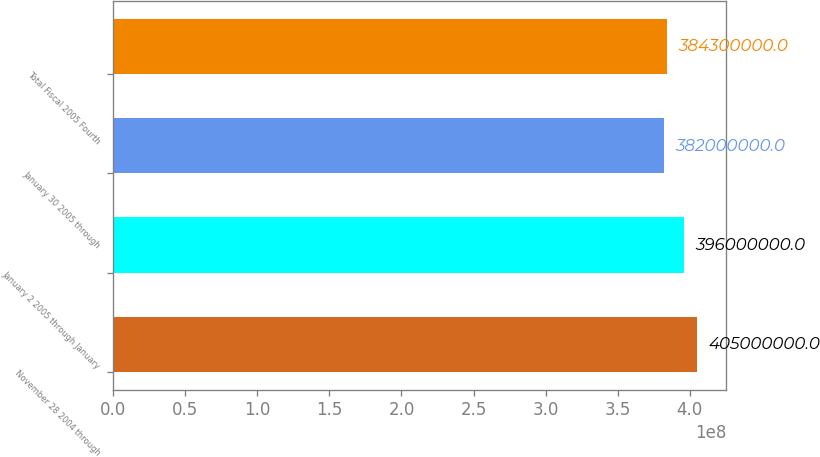<chart> <loc_0><loc_0><loc_500><loc_500><bar_chart><fcel>November 28 2004 through<fcel>January 2 2005 through January<fcel>January 30 2005 through<fcel>Total Fiscal 2005 Fourth<nl><fcel>4.05e+08<fcel>3.96e+08<fcel>3.82e+08<fcel>3.843e+08<nl></chart> 